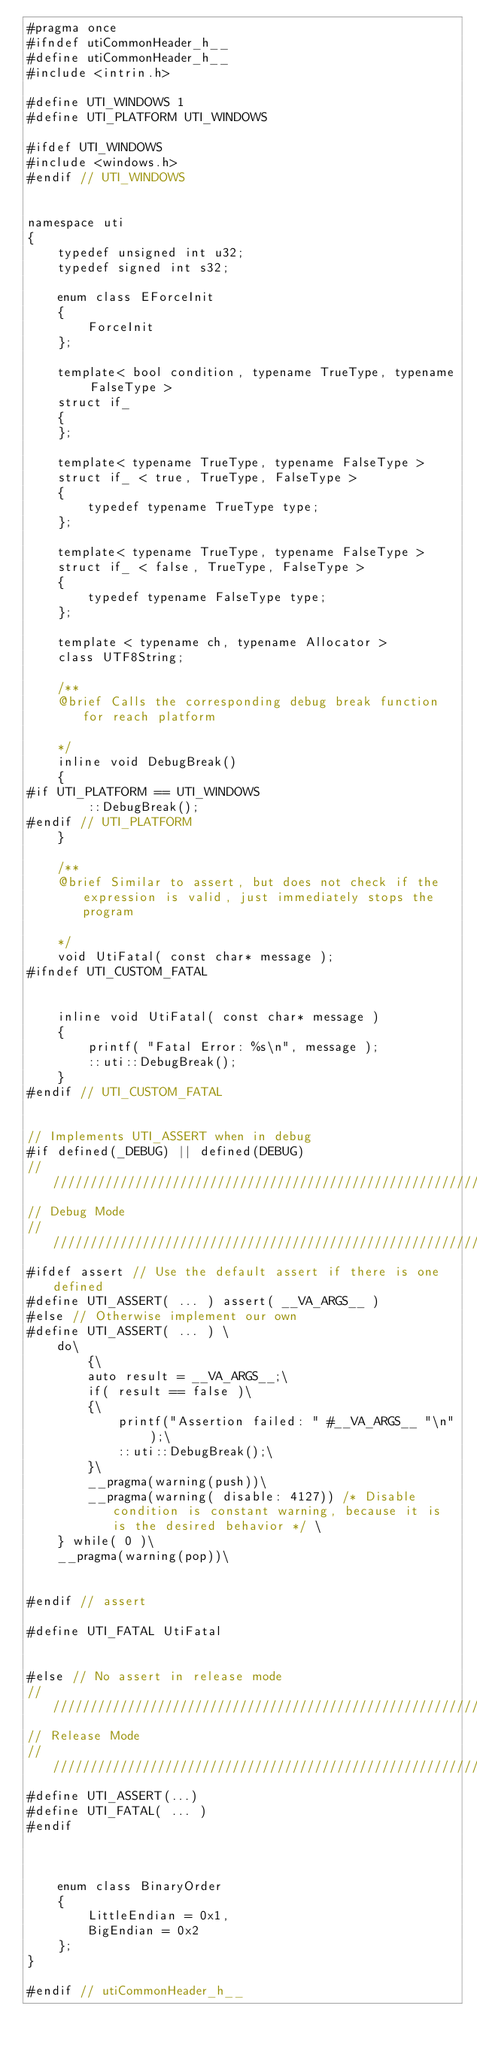Convert code to text. <code><loc_0><loc_0><loc_500><loc_500><_C++_>#pragma once
#ifndef utiCommonHeader_h__
#define utiCommonHeader_h__
#include <intrin.h>

#define UTI_WINDOWS 1
#define UTI_PLATFORM UTI_WINDOWS

#ifdef UTI_WINDOWS
#include <windows.h>
#endif // UTI_WINDOWS


namespace uti
{
	typedef unsigned int u32;
	typedef signed int s32;

	enum class EForceInit
	{
		ForceInit
	};

	template< bool condition, typename TrueType, typename FalseType >
	struct if_
	{
	};

	template< typename TrueType, typename FalseType >
	struct if_ < true, TrueType, FalseType >
	{
		typedef typename TrueType type;
	};

	template< typename TrueType, typename FalseType >
	struct if_ < false, TrueType, FalseType >
	{
		typedef typename FalseType type;
	};

	template < typename ch, typename Allocator >
	class UTF8String;

	/**
	@brief Calls the corresponding debug break function for reach platform

	*/
	inline void DebugBreak()
	{
#if UTI_PLATFORM == UTI_WINDOWS
		::DebugBreak();
#endif // UTI_PLATFORM
	}

	/**
	@brief Similar to assert, but does not check if the expression is valid, just immediately stops the program

	*/
	void UtiFatal( const char* message );
#ifndef UTI_CUSTOM_FATAL


	inline void UtiFatal( const char* message )
	{
		printf( "Fatal Error: %s\n", message );
		::uti::DebugBreak();
	}
#endif // UTI_CUSTOM_FATAL


// Implements UTI_ASSERT when in debug
#if defined(_DEBUG) || defined(DEBUG)
//////////////////////////////////////////////////////////////////////////
// Debug Mode
//////////////////////////////////////////////////////////////////////////
#ifdef assert // Use the default assert if there is one defined
#define UTI_ASSERT( ... ) assert( __VA_ARGS__ )
#else // Otherwise implement our own
#define UTI_ASSERT( ... ) \
	do\
		{\
		auto result = __VA_ARGS__;\
		if( result == false )\
		{\
			printf("Assertion failed: " #__VA_ARGS__ "\n" );\
			::uti::DebugBreak();\
		}\
		__pragma(warning(push))\
		__pragma(warning( disable: 4127)) /* Disable condition is constant warning, because it is is the desired behavior */ \
	} while( 0 )\
	__pragma(warning(pop))\


#endif // assert

#define UTI_FATAL UtiFatal


#else // No assert in release mode
//////////////////////////////////////////////////////////////////////////
// Release Mode
//////////////////////////////////////////////////////////////////////////
#define UTI_ASSERT(...)
#define UTI_FATAL( ... )
#endif



	enum class BinaryOrder
	{
		LittleEndian = 0x1,
		BigEndian = 0x2
	};
}

#endif // utiCommonHeader_h__
</code> 